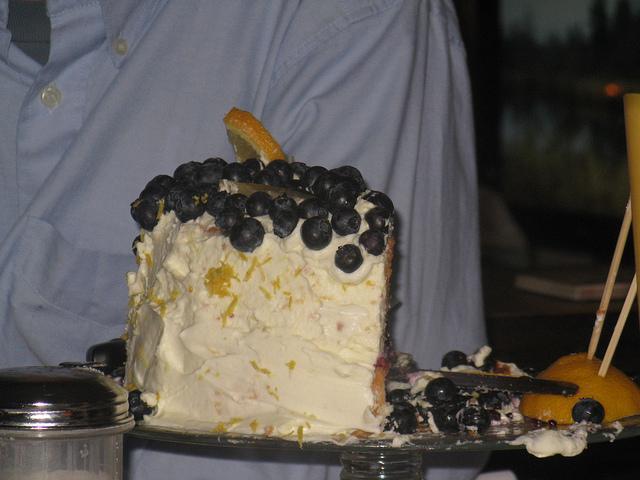How many candy apples are there?
Give a very brief answer. 0. How many oranges are there?
Give a very brief answer. 2. 